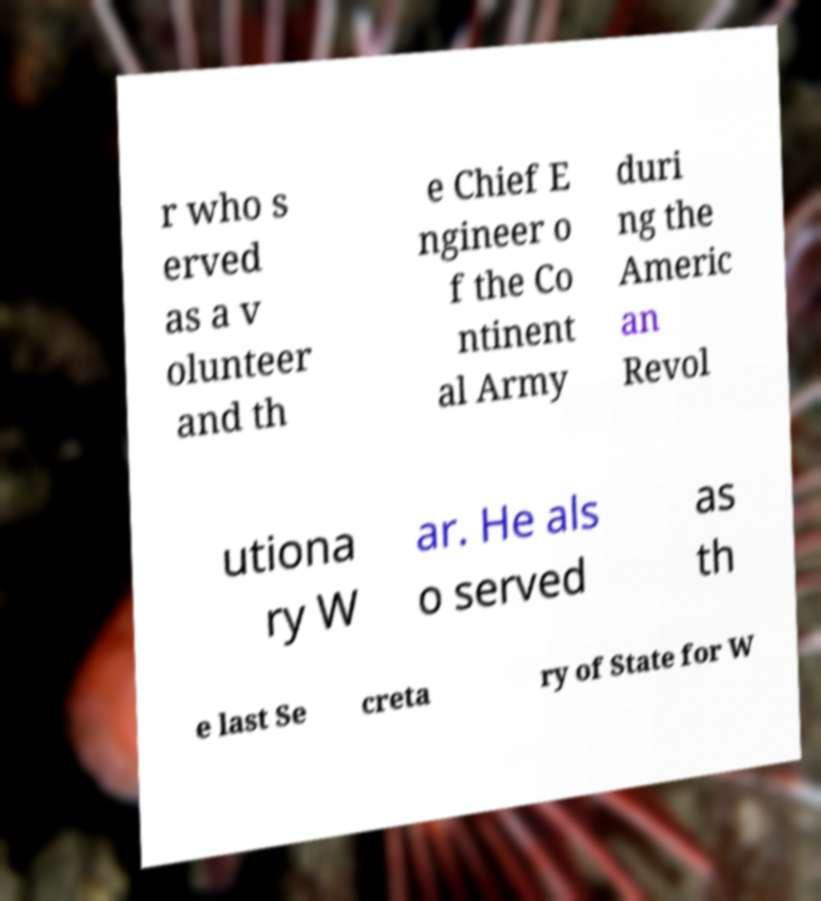I need the written content from this picture converted into text. Can you do that? r who s erved as a v olunteer and th e Chief E ngineer o f the Co ntinent al Army duri ng the Americ an Revol utiona ry W ar. He als o served as th e last Se creta ry of State for W 